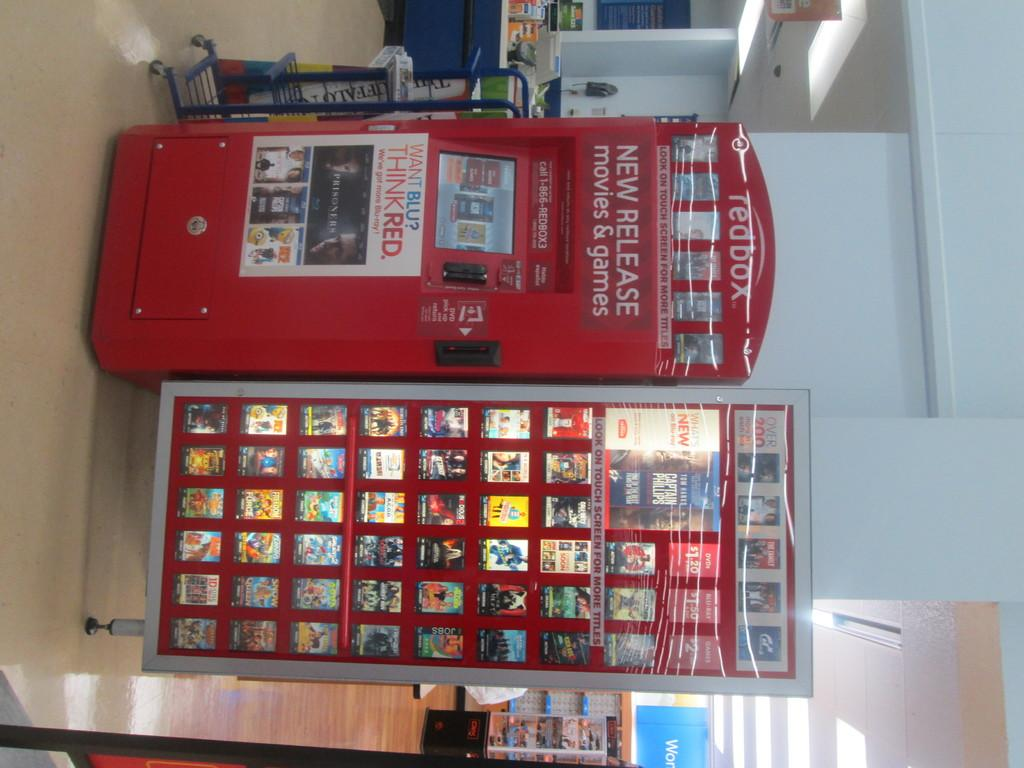<image>
Render a clear and concise summary of the photo. Redbox vending machine that says "New Releases " on it. 